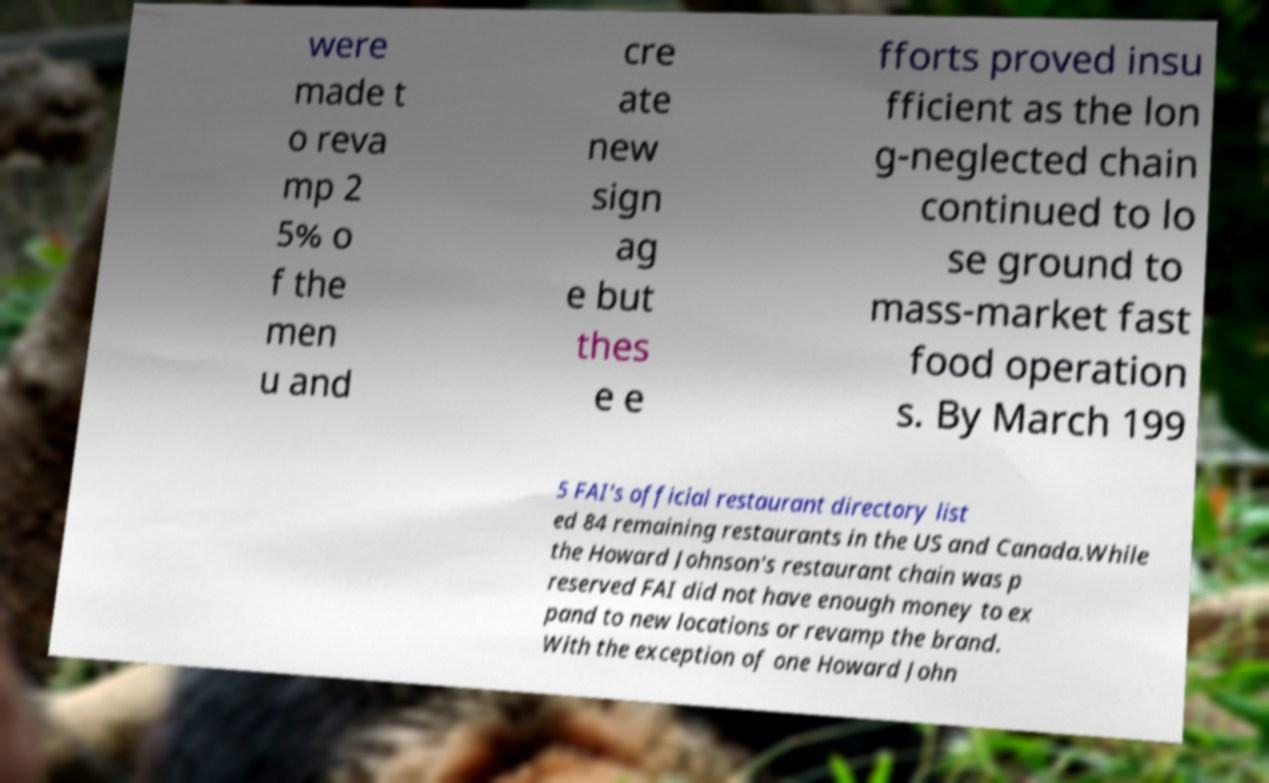There's text embedded in this image that I need extracted. Can you transcribe it verbatim? were made t o reva mp 2 5% o f the men u and cre ate new sign ag e but thes e e fforts proved insu fficient as the lon g-neglected chain continued to lo se ground to mass-market fast food operation s. By March 199 5 FAI's official restaurant directory list ed 84 remaining restaurants in the US and Canada.While the Howard Johnson's restaurant chain was p reserved FAI did not have enough money to ex pand to new locations or revamp the brand. With the exception of one Howard John 